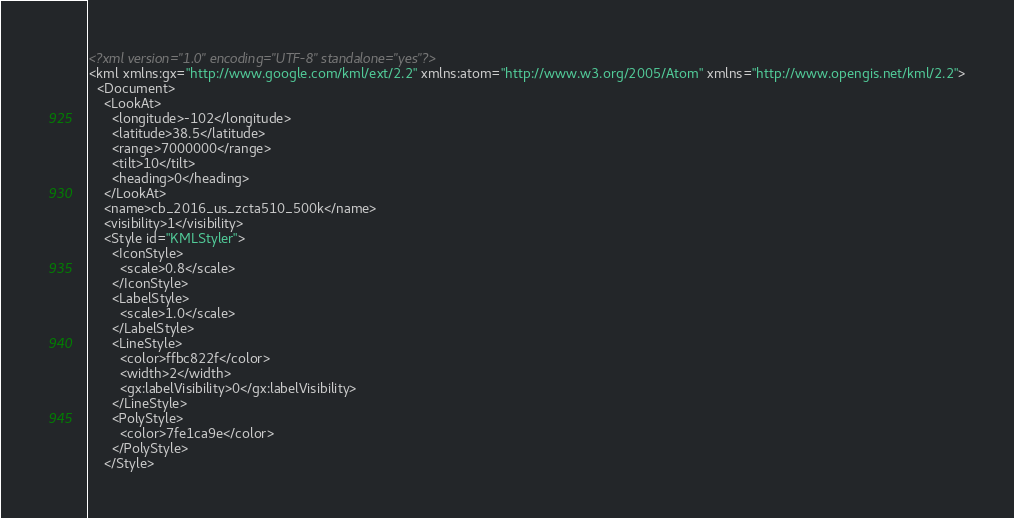<code> <loc_0><loc_0><loc_500><loc_500><_XML_><?xml version="1.0" encoding="UTF-8" standalone="yes"?>
<kml xmlns:gx="http://www.google.com/kml/ext/2.2" xmlns:atom="http://www.w3.org/2005/Atom" xmlns="http://www.opengis.net/kml/2.2">
  <Document>
    <LookAt>
      <longitude>-102</longitude>
      <latitude>38.5</latitude>
      <range>7000000</range>
      <tilt>10</tilt>
      <heading>0</heading>
    </LookAt>
    <name>cb_2016_us_zcta510_500k</name>
    <visibility>1</visibility>
    <Style id="KMLStyler">
      <IconStyle>
        <scale>0.8</scale>
      </IconStyle>
      <LabelStyle>
        <scale>1.0</scale>
      </LabelStyle>
      <LineStyle>
        <color>ffbc822f</color>
        <width>2</width>
        <gx:labelVisibility>0</gx:labelVisibility>
      </LineStyle>
      <PolyStyle>
        <color>7fe1ca9e</color>
      </PolyStyle>
    </Style></code> 